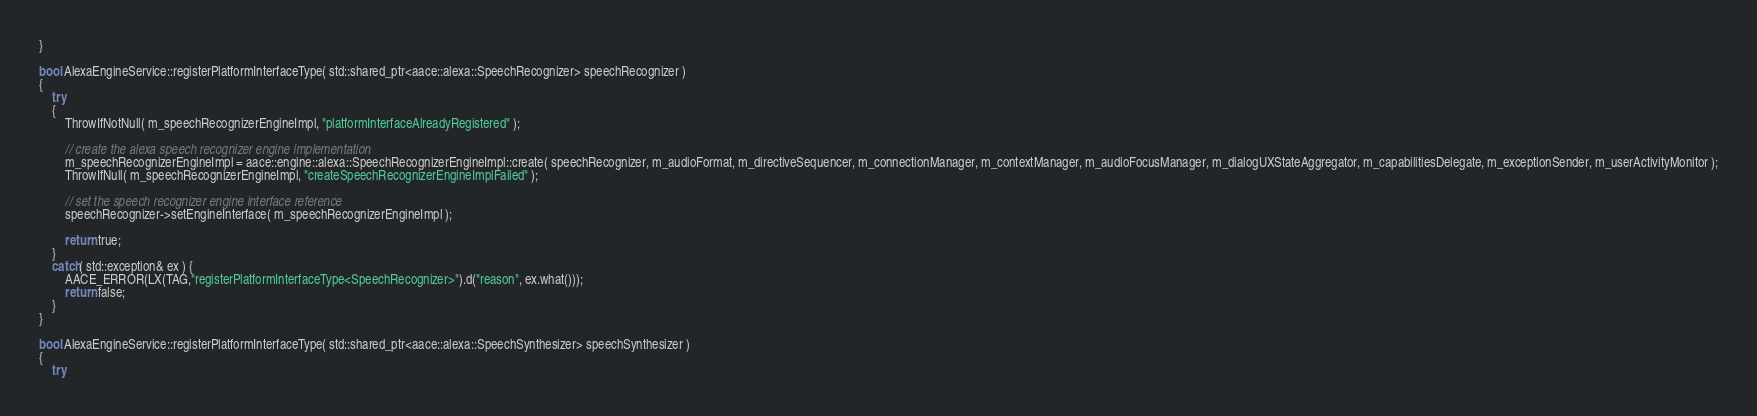<code> <loc_0><loc_0><loc_500><loc_500><_C++_>}

bool AlexaEngineService::registerPlatformInterfaceType( std::shared_ptr<aace::alexa::SpeechRecognizer> speechRecognizer )
{
    try
    {
        ThrowIfNotNull( m_speechRecognizerEngineImpl, "platformInterfaceAlreadyRegistered" );

        // create the alexa speech recognizer engine implementation
        m_speechRecognizerEngineImpl = aace::engine::alexa::SpeechRecognizerEngineImpl::create( speechRecognizer, m_audioFormat, m_directiveSequencer, m_connectionManager, m_contextManager, m_audioFocusManager, m_dialogUXStateAggregator, m_capabilitiesDelegate, m_exceptionSender, m_userActivityMonitor );
        ThrowIfNull( m_speechRecognizerEngineImpl, "createSpeechRecognizerEngineImplFailed" );

        // set the speech recognizer engine interface reference
        speechRecognizer->setEngineInterface( m_speechRecognizerEngineImpl );    

        return true;
    }
    catch( std::exception& ex ) {
        AACE_ERROR(LX(TAG,"registerPlatformInterfaceType<SpeechRecognizer>").d("reason", ex.what()));
        return false;
    }
}

bool AlexaEngineService::registerPlatformInterfaceType( std::shared_ptr<aace::alexa::SpeechSynthesizer> speechSynthesizer )
{
    try</code> 